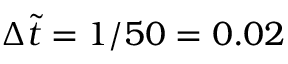Convert formula to latex. <formula><loc_0><loc_0><loc_500><loc_500>\Delta \tilde { t } = 1 / 5 0 = 0 . 0 2</formula> 